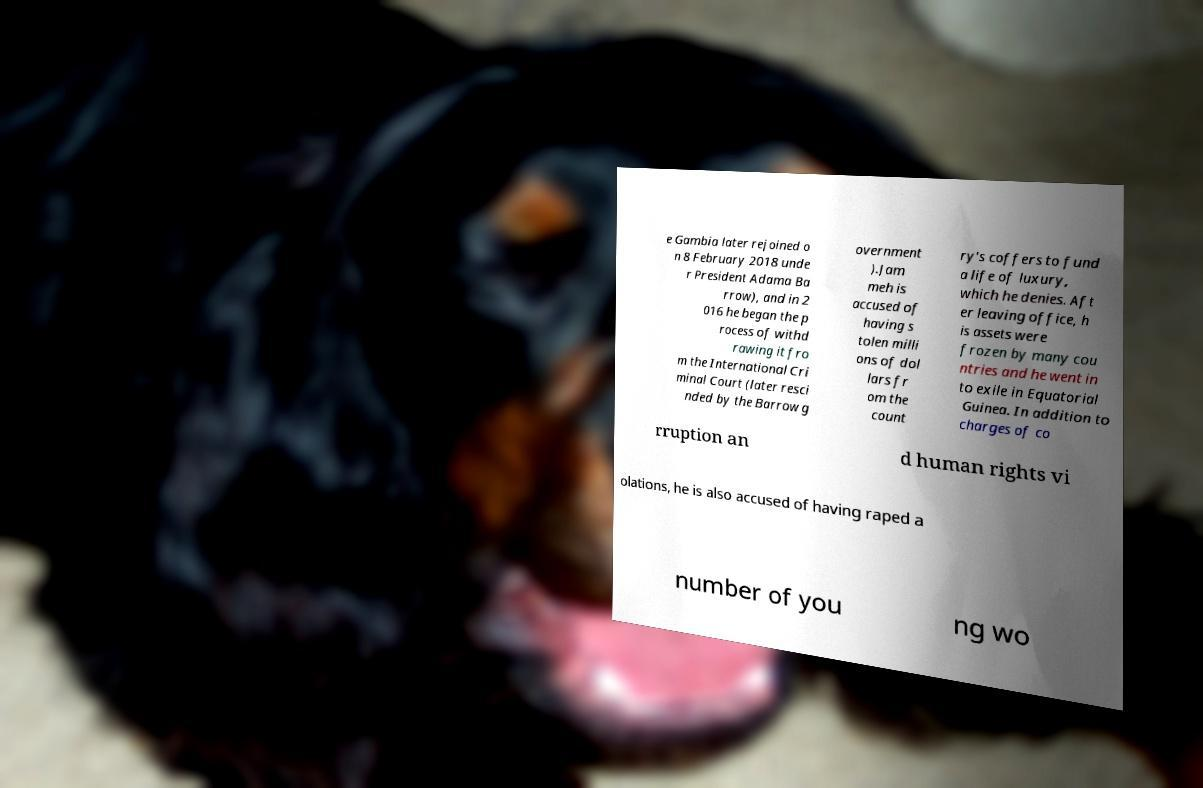Can you accurately transcribe the text from the provided image for me? e Gambia later rejoined o n 8 February 2018 unde r President Adama Ba rrow), and in 2 016 he began the p rocess of withd rawing it fro m the International Cri minal Court (later resci nded by the Barrow g overnment ).Jam meh is accused of having s tolen milli ons of dol lars fr om the count ry's coffers to fund a life of luxury, which he denies. Aft er leaving office, h is assets were frozen by many cou ntries and he went in to exile in Equatorial Guinea. In addition to charges of co rruption an d human rights vi olations, he is also accused of having raped a number of you ng wo 